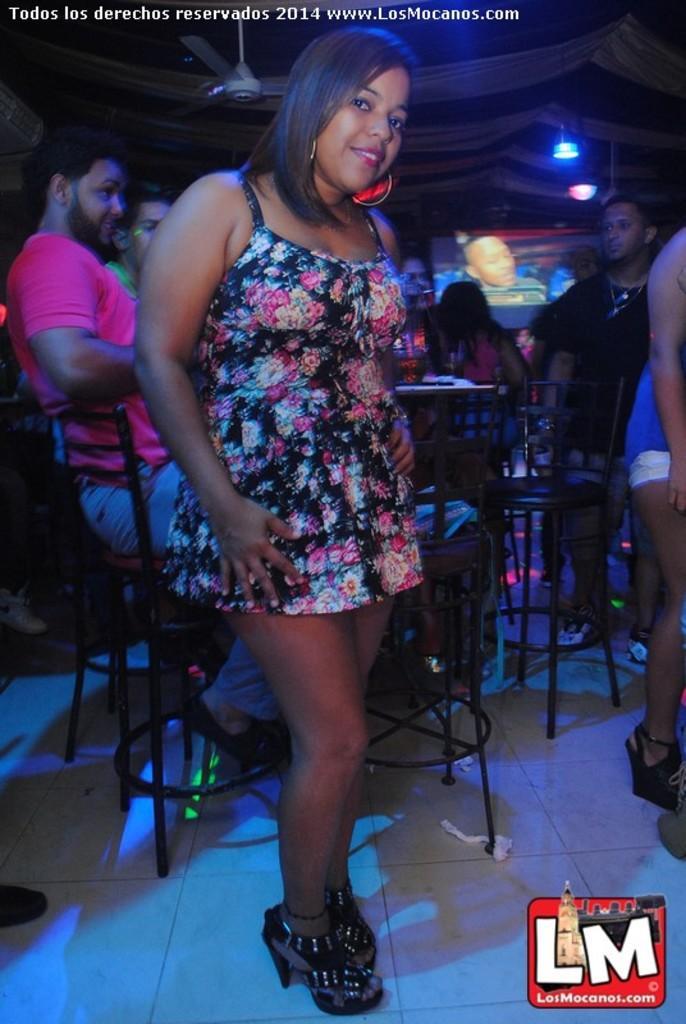Please provide a concise description of this image. In this image I can see some people. I can see the chairs. I can see some objects on the table. At the top I can see a fan and the lights. In the background, I can also see something projected on the screen. 